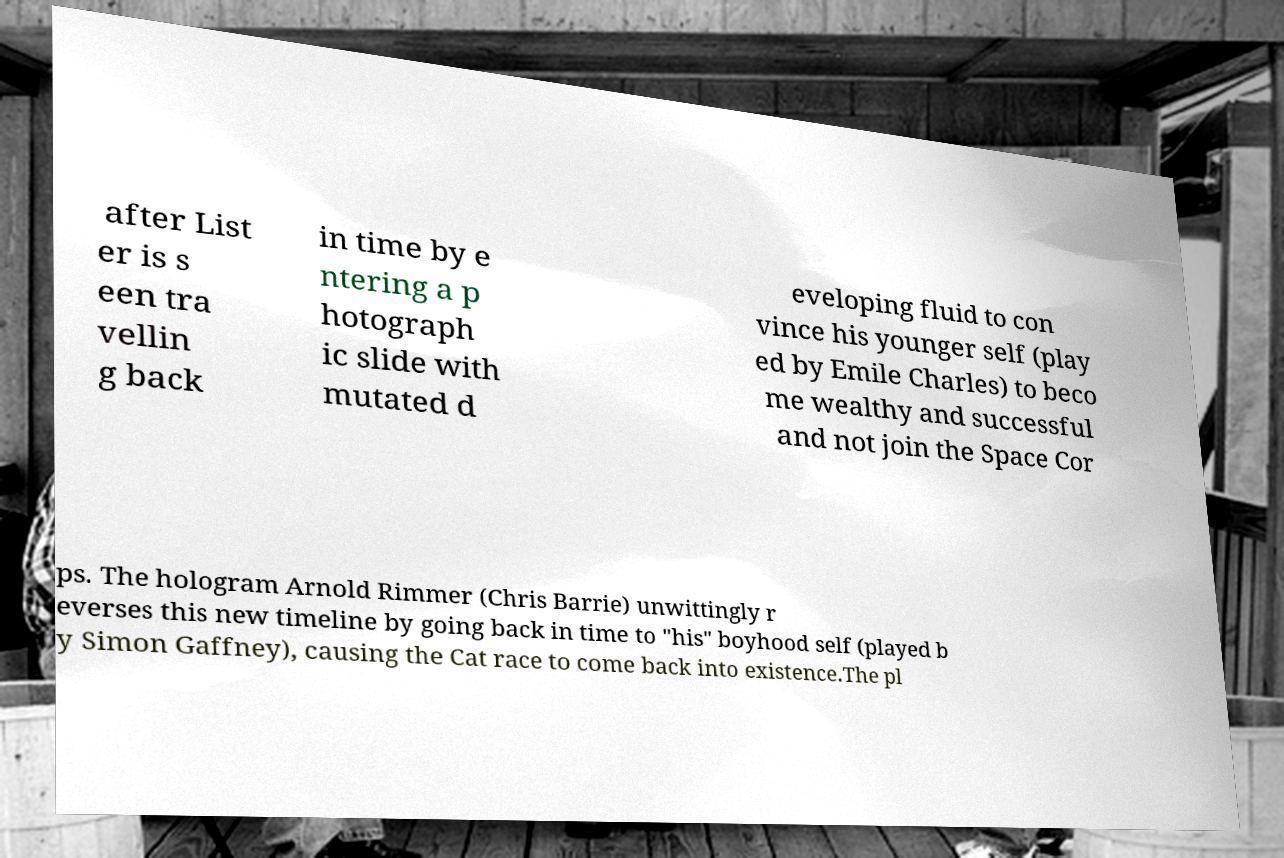Can you read and provide the text displayed in the image?This photo seems to have some interesting text. Can you extract and type it out for me? after List er is s een tra vellin g back in time by e ntering a p hotograph ic slide with mutated d eveloping fluid to con vince his younger self (play ed by Emile Charles) to beco me wealthy and successful and not join the Space Cor ps. The hologram Arnold Rimmer (Chris Barrie) unwittingly r everses this new timeline by going back in time to "his" boyhood self (played b y Simon Gaffney), causing the Cat race to come back into existence.The pl 